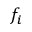<formula> <loc_0><loc_0><loc_500><loc_500>f _ { i }</formula> 